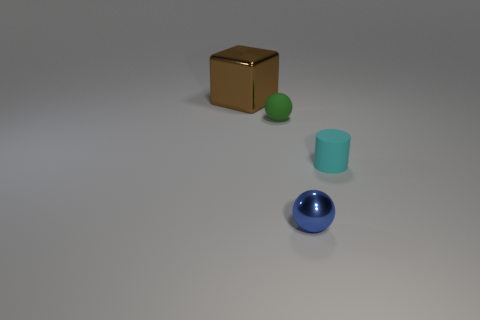There is a big block; how many small blue metal things are on the left side of it?
Give a very brief answer. 0. Is the shape of the big brown thing the same as the green rubber object?
Make the answer very short. No. What number of tiny objects are behind the blue thing and right of the green ball?
Ensure brevity in your answer.  1. How many objects are either gray metallic blocks or objects behind the blue metal ball?
Make the answer very short. 3. Are there more tiny metal cylinders than tiny cyan objects?
Offer a terse response. No. What is the shape of the small matte thing in front of the matte sphere?
Provide a succinct answer. Cylinder. What number of tiny matte things have the same shape as the small blue metal thing?
Give a very brief answer. 1. What is the size of the shiny thing that is behind the metallic thing in front of the brown metal object?
Make the answer very short. Large. How many brown objects are either small things or small cylinders?
Offer a terse response. 0. Are there fewer blocks that are on the right side of the small cyan matte thing than blue metal objects that are left of the green matte sphere?
Give a very brief answer. No. 